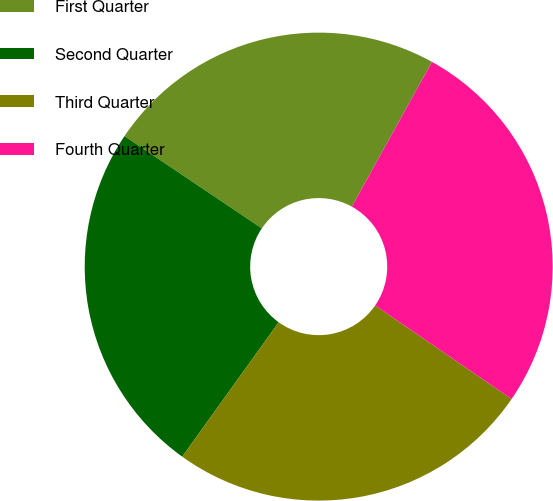Convert chart. <chart><loc_0><loc_0><loc_500><loc_500><pie_chart><fcel>First Quarter<fcel>Second Quarter<fcel>Third Quarter<fcel>Fourth Quarter<nl><fcel>23.63%<fcel>24.51%<fcel>25.34%<fcel>26.53%<nl></chart> 